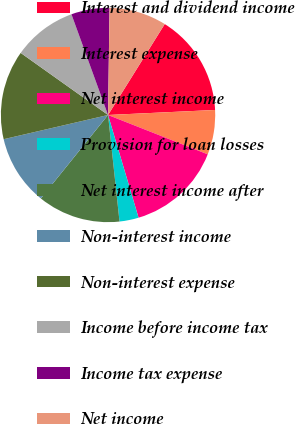Convert chart to OTSL. <chart><loc_0><loc_0><loc_500><loc_500><pie_chart><fcel>Interest and dividend income<fcel>Interest expense<fcel>Net interest income<fcel>Provision for loan losses<fcel>Net interest income after<fcel>Non-interest income<fcel>Non-interest expense<fcel>Income before income tax<fcel>Income tax expense<fcel>Net income<nl><fcel>15.38%<fcel>6.73%<fcel>14.42%<fcel>2.89%<fcel>12.5%<fcel>10.58%<fcel>13.46%<fcel>9.62%<fcel>5.77%<fcel>8.65%<nl></chart> 